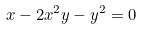<formula> <loc_0><loc_0><loc_500><loc_500>x - 2 x ^ { 2 } y - y ^ { 2 } = 0</formula> 